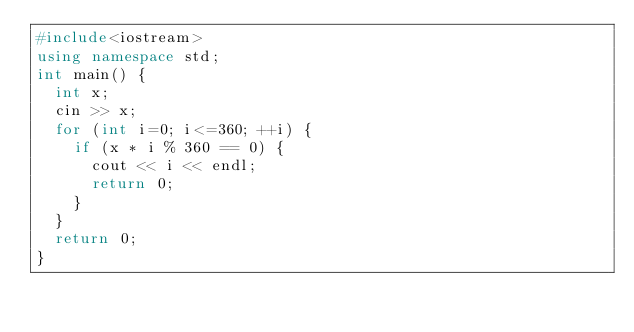<code> <loc_0><loc_0><loc_500><loc_500><_C++_>#include<iostream>
using namespace std;
int main() {
  int x;
  cin >> x;
  for (int i=0; i<=360; ++i) {
    if (x * i % 360 == 0) {
      cout << i << endl;
      return 0;
    }
  }
  return 0;
}
</code> 